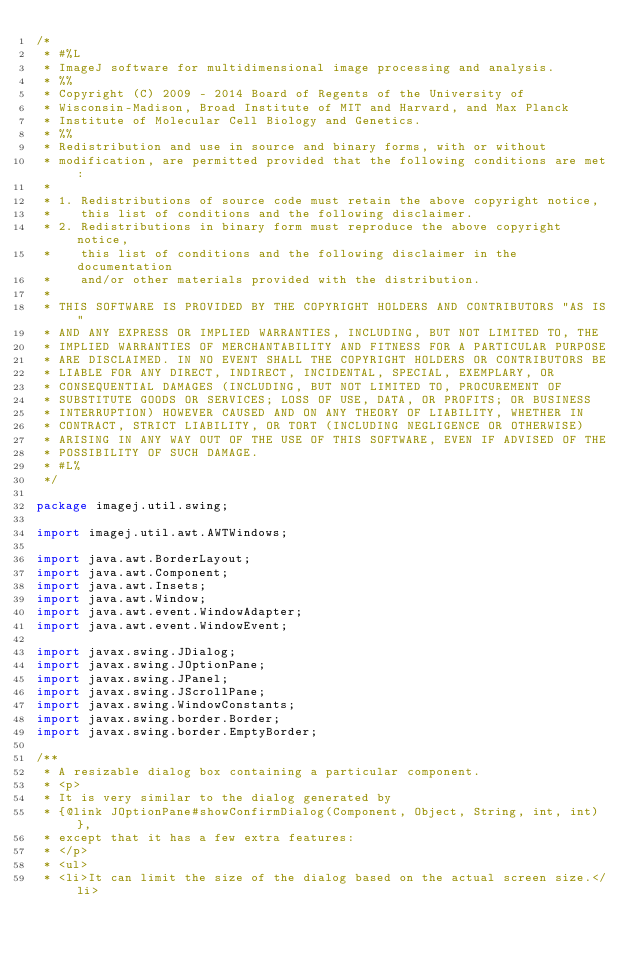Convert code to text. <code><loc_0><loc_0><loc_500><loc_500><_Java_>/*
 * #%L
 * ImageJ software for multidimensional image processing and analysis.
 * %%
 * Copyright (C) 2009 - 2014 Board of Regents of the University of
 * Wisconsin-Madison, Broad Institute of MIT and Harvard, and Max Planck
 * Institute of Molecular Cell Biology and Genetics.
 * %%
 * Redistribution and use in source and binary forms, with or without
 * modification, are permitted provided that the following conditions are met:
 * 
 * 1. Redistributions of source code must retain the above copyright notice,
 *    this list of conditions and the following disclaimer.
 * 2. Redistributions in binary form must reproduce the above copyright notice,
 *    this list of conditions and the following disclaimer in the documentation
 *    and/or other materials provided with the distribution.
 * 
 * THIS SOFTWARE IS PROVIDED BY THE COPYRIGHT HOLDERS AND CONTRIBUTORS "AS IS"
 * AND ANY EXPRESS OR IMPLIED WARRANTIES, INCLUDING, BUT NOT LIMITED TO, THE
 * IMPLIED WARRANTIES OF MERCHANTABILITY AND FITNESS FOR A PARTICULAR PURPOSE
 * ARE DISCLAIMED. IN NO EVENT SHALL THE COPYRIGHT HOLDERS OR CONTRIBUTORS BE
 * LIABLE FOR ANY DIRECT, INDIRECT, INCIDENTAL, SPECIAL, EXEMPLARY, OR
 * CONSEQUENTIAL DAMAGES (INCLUDING, BUT NOT LIMITED TO, PROCUREMENT OF
 * SUBSTITUTE GOODS OR SERVICES; LOSS OF USE, DATA, OR PROFITS; OR BUSINESS
 * INTERRUPTION) HOWEVER CAUSED AND ON ANY THEORY OF LIABILITY, WHETHER IN
 * CONTRACT, STRICT LIABILITY, OR TORT (INCLUDING NEGLIGENCE OR OTHERWISE)
 * ARISING IN ANY WAY OUT OF THE USE OF THIS SOFTWARE, EVEN IF ADVISED OF THE
 * POSSIBILITY OF SUCH DAMAGE.
 * #L%
 */

package imagej.util.swing;

import imagej.util.awt.AWTWindows;

import java.awt.BorderLayout;
import java.awt.Component;
import java.awt.Insets;
import java.awt.Window;
import java.awt.event.WindowAdapter;
import java.awt.event.WindowEvent;

import javax.swing.JDialog;
import javax.swing.JOptionPane;
import javax.swing.JPanel;
import javax.swing.JScrollPane;
import javax.swing.WindowConstants;
import javax.swing.border.Border;
import javax.swing.border.EmptyBorder;

/**
 * A resizable dialog box containing a particular component.
 * <p>
 * It is very similar to the dialog generated by
 * {@link JOptionPane#showConfirmDialog(Component, Object, String, int, int)},
 * except that it has a few extra features:
 * </p>
 * <ul>
 * <li>It can limit the size of the dialog based on the actual screen size.</li></code> 